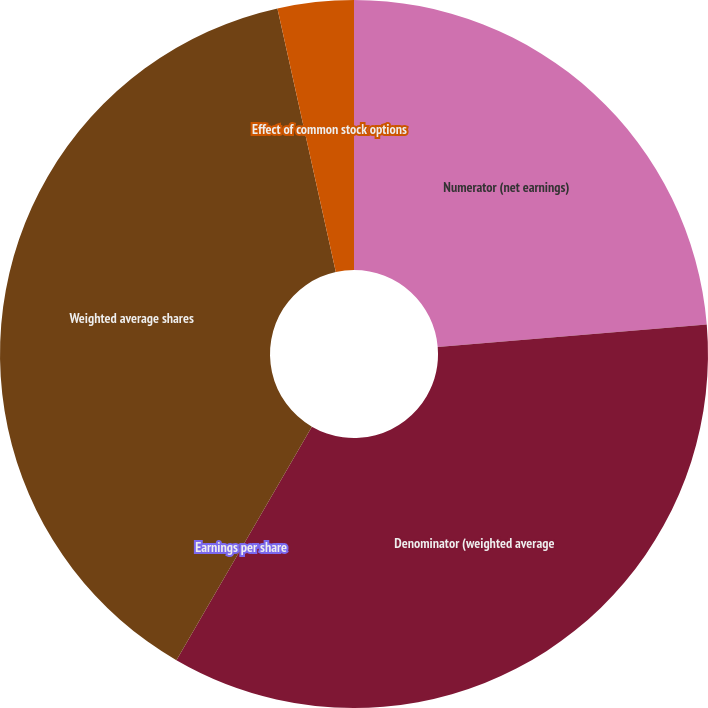Convert chart. <chart><loc_0><loc_0><loc_500><loc_500><pie_chart><fcel>Numerator (net earnings)<fcel>Denominator (weighted average<fcel>Earnings per share<fcel>Weighted average shares<fcel>Effect of common stock options<nl><fcel>23.67%<fcel>34.7%<fcel>0.0%<fcel>38.17%<fcel>3.47%<nl></chart> 